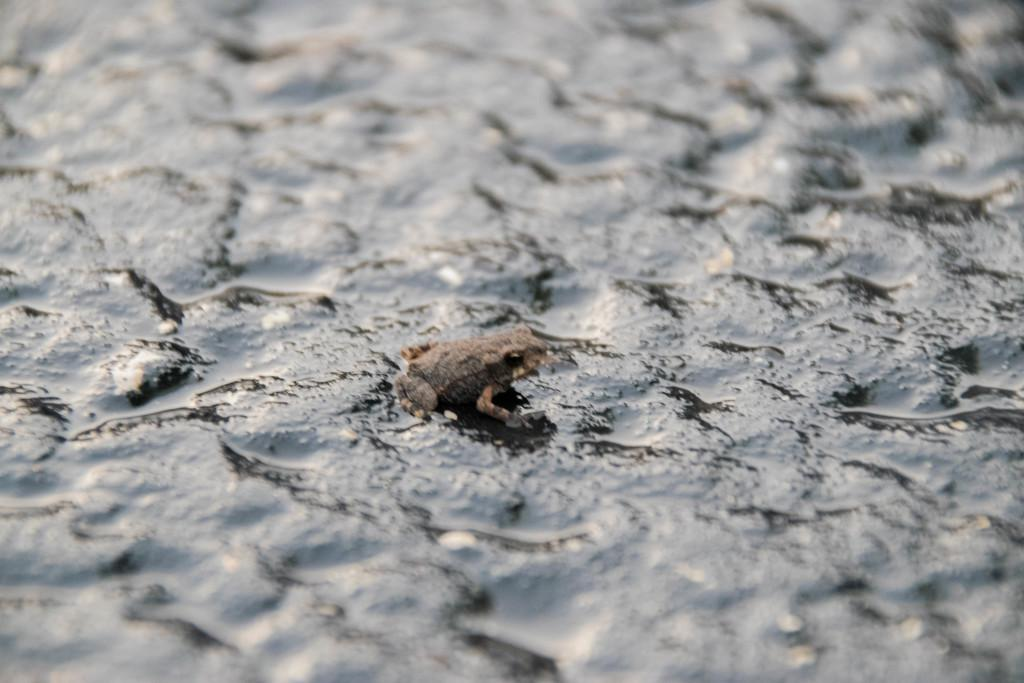What type of animal is present in the image? There is a frog in the image. Where is the frog located in the image? The frog is on a rock. What type of curtain can be seen hanging from the frog's mouth in the image? There is no curtain present in the image, and the frog's mouth is not depicted as hanging any object. 